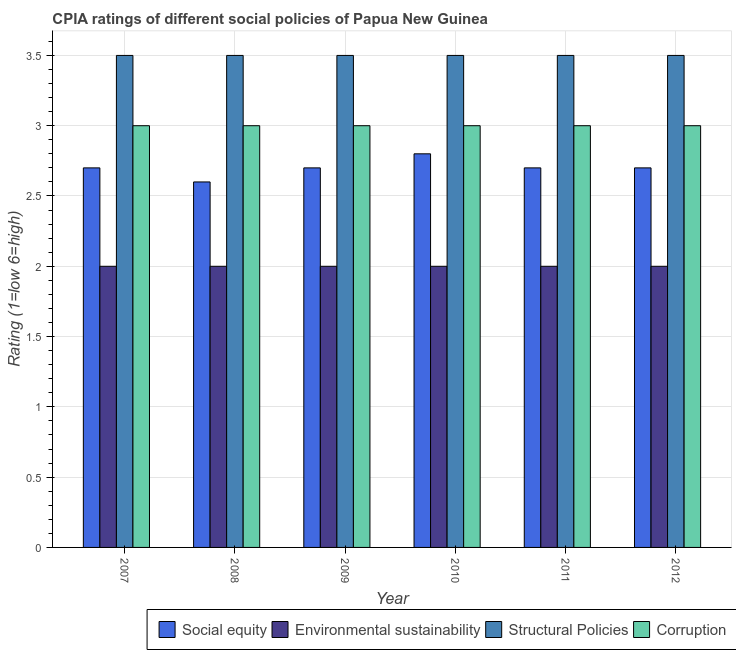How many different coloured bars are there?
Keep it short and to the point. 4. How many groups of bars are there?
Provide a succinct answer. 6. Are the number of bars per tick equal to the number of legend labels?
Make the answer very short. Yes. What is the label of the 5th group of bars from the left?
Provide a succinct answer. 2011. In how many cases, is the number of bars for a given year not equal to the number of legend labels?
Your response must be concise. 0. What is the cpia rating of social equity in 2008?
Offer a terse response. 2.6. Across all years, what is the maximum cpia rating of structural policies?
Ensure brevity in your answer.  3.5. Across all years, what is the minimum cpia rating of social equity?
Offer a very short reply. 2.6. In which year was the cpia rating of corruption maximum?
Offer a terse response. 2007. What is the difference between the cpia rating of social equity in 2009 and the cpia rating of corruption in 2011?
Keep it short and to the point. 0. What is the average cpia rating of environmental sustainability per year?
Offer a very short reply. 2. In how many years, is the cpia rating of social equity greater than 3?
Your answer should be very brief. 0. Is the cpia rating of social equity in 2007 less than that in 2012?
Provide a succinct answer. No. Is the difference between the cpia rating of environmental sustainability in 2007 and 2009 greater than the difference between the cpia rating of corruption in 2007 and 2009?
Ensure brevity in your answer.  No. What is the difference between the highest and the second highest cpia rating of environmental sustainability?
Ensure brevity in your answer.  0. Is it the case that in every year, the sum of the cpia rating of structural policies and cpia rating of corruption is greater than the sum of cpia rating of social equity and cpia rating of environmental sustainability?
Your answer should be very brief. Yes. What does the 3rd bar from the left in 2008 represents?
Provide a succinct answer. Structural Policies. What does the 1st bar from the right in 2010 represents?
Ensure brevity in your answer.  Corruption. How many bars are there?
Provide a succinct answer. 24. What is the difference between two consecutive major ticks on the Y-axis?
Make the answer very short. 0.5. Does the graph contain any zero values?
Your answer should be very brief. No. Where does the legend appear in the graph?
Make the answer very short. Bottom right. How many legend labels are there?
Your answer should be compact. 4. What is the title of the graph?
Give a very brief answer. CPIA ratings of different social policies of Papua New Guinea. What is the label or title of the X-axis?
Your answer should be very brief. Year. What is the Rating (1=low 6=high) of Environmental sustainability in 2007?
Offer a very short reply. 2. What is the Rating (1=low 6=high) in Structural Policies in 2007?
Give a very brief answer. 3.5. What is the Rating (1=low 6=high) in Structural Policies in 2008?
Provide a short and direct response. 3.5. What is the Rating (1=low 6=high) of Corruption in 2008?
Keep it short and to the point. 3. What is the Rating (1=low 6=high) of Environmental sustainability in 2010?
Offer a terse response. 2. What is the Rating (1=low 6=high) of Structural Policies in 2010?
Keep it short and to the point. 3.5. What is the Rating (1=low 6=high) of Environmental sustainability in 2011?
Give a very brief answer. 2. What is the Rating (1=low 6=high) of Environmental sustainability in 2012?
Ensure brevity in your answer.  2. What is the Rating (1=low 6=high) of Structural Policies in 2012?
Provide a short and direct response. 3.5. What is the Rating (1=low 6=high) in Corruption in 2012?
Provide a short and direct response. 3. Across all years, what is the maximum Rating (1=low 6=high) in Social equity?
Your response must be concise. 2.8. Across all years, what is the maximum Rating (1=low 6=high) in Environmental sustainability?
Your response must be concise. 2. Across all years, what is the maximum Rating (1=low 6=high) of Structural Policies?
Make the answer very short. 3.5. Across all years, what is the minimum Rating (1=low 6=high) of Social equity?
Your answer should be compact. 2.6. What is the total Rating (1=low 6=high) in Social equity in the graph?
Offer a terse response. 16.2. What is the difference between the Rating (1=low 6=high) in Structural Policies in 2007 and that in 2008?
Provide a succinct answer. 0. What is the difference between the Rating (1=low 6=high) in Corruption in 2007 and that in 2008?
Give a very brief answer. 0. What is the difference between the Rating (1=low 6=high) in Social equity in 2007 and that in 2009?
Provide a succinct answer. 0. What is the difference between the Rating (1=low 6=high) in Structural Policies in 2007 and that in 2009?
Your response must be concise. 0. What is the difference between the Rating (1=low 6=high) in Social equity in 2007 and that in 2011?
Your answer should be compact. 0. What is the difference between the Rating (1=low 6=high) in Structural Policies in 2007 and that in 2011?
Provide a short and direct response. 0. What is the difference between the Rating (1=low 6=high) in Social equity in 2007 and that in 2012?
Your answer should be very brief. 0. What is the difference between the Rating (1=low 6=high) in Corruption in 2007 and that in 2012?
Your answer should be compact. 0. What is the difference between the Rating (1=low 6=high) of Corruption in 2008 and that in 2010?
Your response must be concise. 0. What is the difference between the Rating (1=low 6=high) in Social equity in 2008 and that in 2011?
Your answer should be very brief. -0.1. What is the difference between the Rating (1=low 6=high) of Environmental sustainability in 2008 and that in 2011?
Offer a very short reply. 0. What is the difference between the Rating (1=low 6=high) of Social equity in 2008 and that in 2012?
Your answer should be compact. -0.1. What is the difference between the Rating (1=low 6=high) of Structural Policies in 2008 and that in 2012?
Your answer should be compact. 0. What is the difference between the Rating (1=low 6=high) of Social equity in 2009 and that in 2010?
Offer a terse response. -0.1. What is the difference between the Rating (1=low 6=high) in Environmental sustainability in 2009 and that in 2010?
Provide a succinct answer. 0. What is the difference between the Rating (1=low 6=high) of Structural Policies in 2009 and that in 2010?
Your answer should be compact. 0. What is the difference between the Rating (1=low 6=high) in Corruption in 2009 and that in 2010?
Provide a succinct answer. 0. What is the difference between the Rating (1=low 6=high) in Environmental sustainability in 2009 and that in 2011?
Provide a succinct answer. 0. What is the difference between the Rating (1=low 6=high) of Environmental sustainability in 2009 and that in 2012?
Ensure brevity in your answer.  0. What is the difference between the Rating (1=low 6=high) in Corruption in 2009 and that in 2012?
Give a very brief answer. 0. What is the difference between the Rating (1=low 6=high) of Social equity in 2010 and that in 2011?
Provide a short and direct response. 0.1. What is the difference between the Rating (1=low 6=high) of Social equity in 2010 and that in 2012?
Ensure brevity in your answer.  0.1. What is the difference between the Rating (1=low 6=high) of Environmental sustainability in 2010 and that in 2012?
Keep it short and to the point. 0. What is the difference between the Rating (1=low 6=high) in Structural Policies in 2011 and that in 2012?
Your answer should be compact. 0. What is the difference between the Rating (1=low 6=high) in Corruption in 2011 and that in 2012?
Ensure brevity in your answer.  0. What is the difference between the Rating (1=low 6=high) in Environmental sustainability in 2007 and the Rating (1=low 6=high) in Corruption in 2008?
Provide a succinct answer. -1. What is the difference between the Rating (1=low 6=high) of Social equity in 2007 and the Rating (1=low 6=high) of Environmental sustainability in 2009?
Ensure brevity in your answer.  0.7. What is the difference between the Rating (1=low 6=high) of Social equity in 2007 and the Rating (1=low 6=high) of Structural Policies in 2009?
Offer a terse response. -0.8. What is the difference between the Rating (1=low 6=high) in Social equity in 2007 and the Rating (1=low 6=high) in Corruption in 2009?
Keep it short and to the point. -0.3. What is the difference between the Rating (1=low 6=high) of Environmental sustainability in 2007 and the Rating (1=low 6=high) of Structural Policies in 2009?
Keep it short and to the point. -1.5. What is the difference between the Rating (1=low 6=high) of Social equity in 2007 and the Rating (1=low 6=high) of Corruption in 2010?
Provide a short and direct response. -0.3. What is the difference between the Rating (1=low 6=high) in Environmental sustainability in 2007 and the Rating (1=low 6=high) in Structural Policies in 2010?
Your answer should be compact. -1.5. What is the difference between the Rating (1=low 6=high) of Social equity in 2007 and the Rating (1=low 6=high) of Environmental sustainability in 2011?
Ensure brevity in your answer.  0.7. What is the difference between the Rating (1=low 6=high) of Environmental sustainability in 2007 and the Rating (1=low 6=high) of Corruption in 2011?
Your answer should be compact. -1. What is the difference between the Rating (1=low 6=high) of Social equity in 2007 and the Rating (1=low 6=high) of Environmental sustainability in 2012?
Offer a terse response. 0.7. What is the difference between the Rating (1=low 6=high) in Social equity in 2008 and the Rating (1=low 6=high) in Environmental sustainability in 2009?
Your response must be concise. 0.6. What is the difference between the Rating (1=low 6=high) in Social equity in 2008 and the Rating (1=low 6=high) in Corruption in 2009?
Keep it short and to the point. -0.4. What is the difference between the Rating (1=low 6=high) in Structural Policies in 2008 and the Rating (1=low 6=high) in Corruption in 2009?
Offer a very short reply. 0.5. What is the difference between the Rating (1=low 6=high) in Social equity in 2008 and the Rating (1=low 6=high) in Environmental sustainability in 2010?
Ensure brevity in your answer.  0.6. What is the difference between the Rating (1=low 6=high) in Social equity in 2008 and the Rating (1=low 6=high) in Corruption in 2010?
Ensure brevity in your answer.  -0.4. What is the difference between the Rating (1=low 6=high) of Environmental sustainability in 2008 and the Rating (1=low 6=high) of Structural Policies in 2010?
Make the answer very short. -1.5. What is the difference between the Rating (1=low 6=high) in Environmental sustainability in 2008 and the Rating (1=low 6=high) in Corruption in 2010?
Keep it short and to the point. -1. What is the difference between the Rating (1=low 6=high) in Structural Policies in 2008 and the Rating (1=low 6=high) in Corruption in 2010?
Make the answer very short. 0.5. What is the difference between the Rating (1=low 6=high) of Social equity in 2008 and the Rating (1=low 6=high) of Structural Policies in 2011?
Keep it short and to the point. -0.9. What is the difference between the Rating (1=low 6=high) in Social equity in 2008 and the Rating (1=low 6=high) in Corruption in 2011?
Make the answer very short. -0.4. What is the difference between the Rating (1=low 6=high) in Environmental sustainability in 2008 and the Rating (1=low 6=high) in Structural Policies in 2011?
Ensure brevity in your answer.  -1.5. What is the difference between the Rating (1=low 6=high) of Environmental sustainability in 2008 and the Rating (1=low 6=high) of Corruption in 2011?
Your answer should be compact. -1. What is the difference between the Rating (1=low 6=high) of Structural Policies in 2008 and the Rating (1=low 6=high) of Corruption in 2011?
Ensure brevity in your answer.  0.5. What is the difference between the Rating (1=low 6=high) in Social equity in 2008 and the Rating (1=low 6=high) in Environmental sustainability in 2012?
Keep it short and to the point. 0.6. What is the difference between the Rating (1=low 6=high) of Social equity in 2008 and the Rating (1=low 6=high) of Structural Policies in 2012?
Make the answer very short. -0.9. What is the difference between the Rating (1=low 6=high) of Social equity in 2008 and the Rating (1=low 6=high) of Corruption in 2012?
Provide a short and direct response. -0.4. What is the difference between the Rating (1=low 6=high) of Environmental sustainability in 2008 and the Rating (1=low 6=high) of Structural Policies in 2012?
Your response must be concise. -1.5. What is the difference between the Rating (1=low 6=high) in Social equity in 2009 and the Rating (1=low 6=high) in Structural Policies in 2010?
Give a very brief answer. -0.8. What is the difference between the Rating (1=low 6=high) in Environmental sustainability in 2009 and the Rating (1=low 6=high) in Structural Policies in 2010?
Ensure brevity in your answer.  -1.5. What is the difference between the Rating (1=low 6=high) in Environmental sustainability in 2009 and the Rating (1=low 6=high) in Corruption in 2010?
Ensure brevity in your answer.  -1. What is the difference between the Rating (1=low 6=high) of Social equity in 2009 and the Rating (1=low 6=high) of Corruption in 2011?
Provide a short and direct response. -0.3. What is the difference between the Rating (1=low 6=high) in Social equity in 2009 and the Rating (1=low 6=high) in Environmental sustainability in 2012?
Ensure brevity in your answer.  0.7. What is the difference between the Rating (1=low 6=high) in Social equity in 2009 and the Rating (1=low 6=high) in Structural Policies in 2012?
Offer a very short reply. -0.8. What is the difference between the Rating (1=low 6=high) in Environmental sustainability in 2009 and the Rating (1=low 6=high) in Structural Policies in 2012?
Your answer should be very brief. -1.5. What is the difference between the Rating (1=low 6=high) of Environmental sustainability in 2009 and the Rating (1=low 6=high) of Corruption in 2012?
Provide a succinct answer. -1. What is the difference between the Rating (1=low 6=high) in Social equity in 2010 and the Rating (1=low 6=high) in Structural Policies in 2011?
Offer a very short reply. -0.7. What is the difference between the Rating (1=low 6=high) of Environmental sustainability in 2010 and the Rating (1=low 6=high) of Structural Policies in 2011?
Provide a succinct answer. -1.5. What is the difference between the Rating (1=low 6=high) in Structural Policies in 2010 and the Rating (1=low 6=high) in Corruption in 2011?
Offer a terse response. 0.5. What is the difference between the Rating (1=low 6=high) of Social equity in 2010 and the Rating (1=low 6=high) of Environmental sustainability in 2012?
Your answer should be compact. 0.8. What is the difference between the Rating (1=low 6=high) in Social equity in 2010 and the Rating (1=low 6=high) in Structural Policies in 2012?
Make the answer very short. -0.7. What is the difference between the Rating (1=low 6=high) of Social equity in 2010 and the Rating (1=low 6=high) of Corruption in 2012?
Provide a short and direct response. -0.2. What is the difference between the Rating (1=low 6=high) in Environmental sustainability in 2010 and the Rating (1=low 6=high) in Corruption in 2012?
Provide a short and direct response. -1. What is the difference between the Rating (1=low 6=high) of Social equity in 2011 and the Rating (1=low 6=high) of Environmental sustainability in 2012?
Your response must be concise. 0.7. What is the difference between the Rating (1=low 6=high) in Social equity in 2011 and the Rating (1=low 6=high) in Structural Policies in 2012?
Provide a short and direct response. -0.8. What is the average Rating (1=low 6=high) of Environmental sustainability per year?
Provide a succinct answer. 2. In the year 2007, what is the difference between the Rating (1=low 6=high) in Environmental sustainability and Rating (1=low 6=high) in Structural Policies?
Make the answer very short. -1.5. In the year 2007, what is the difference between the Rating (1=low 6=high) of Environmental sustainability and Rating (1=low 6=high) of Corruption?
Make the answer very short. -1. In the year 2007, what is the difference between the Rating (1=low 6=high) in Structural Policies and Rating (1=low 6=high) in Corruption?
Offer a very short reply. 0.5. In the year 2008, what is the difference between the Rating (1=low 6=high) in Social equity and Rating (1=low 6=high) in Environmental sustainability?
Offer a terse response. 0.6. In the year 2008, what is the difference between the Rating (1=low 6=high) in Social equity and Rating (1=low 6=high) in Corruption?
Your answer should be very brief. -0.4. In the year 2008, what is the difference between the Rating (1=low 6=high) in Environmental sustainability and Rating (1=low 6=high) in Structural Policies?
Keep it short and to the point. -1.5. In the year 2009, what is the difference between the Rating (1=low 6=high) in Social equity and Rating (1=low 6=high) in Environmental sustainability?
Ensure brevity in your answer.  0.7. In the year 2009, what is the difference between the Rating (1=low 6=high) of Social equity and Rating (1=low 6=high) of Structural Policies?
Provide a short and direct response. -0.8. In the year 2009, what is the difference between the Rating (1=low 6=high) of Social equity and Rating (1=low 6=high) of Corruption?
Give a very brief answer. -0.3. In the year 2009, what is the difference between the Rating (1=low 6=high) in Environmental sustainability and Rating (1=low 6=high) in Structural Policies?
Provide a short and direct response. -1.5. In the year 2010, what is the difference between the Rating (1=low 6=high) in Social equity and Rating (1=low 6=high) in Structural Policies?
Offer a very short reply. -0.7. In the year 2010, what is the difference between the Rating (1=low 6=high) of Environmental sustainability and Rating (1=low 6=high) of Structural Policies?
Make the answer very short. -1.5. In the year 2010, what is the difference between the Rating (1=low 6=high) in Environmental sustainability and Rating (1=low 6=high) in Corruption?
Provide a succinct answer. -1. In the year 2011, what is the difference between the Rating (1=low 6=high) in Social equity and Rating (1=low 6=high) in Structural Policies?
Provide a succinct answer. -0.8. In the year 2011, what is the difference between the Rating (1=low 6=high) of Environmental sustainability and Rating (1=low 6=high) of Corruption?
Give a very brief answer. -1. In the year 2012, what is the difference between the Rating (1=low 6=high) of Social equity and Rating (1=low 6=high) of Environmental sustainability?
Give a very brief answer. 0.7. In the year 2012, what is the difference between the Rating (1=low 6=high) in Environmental sustainability and Rating (1=low 6=high) in Structural Policies?
Offer a terse response. -1.5. In the year 2012, what is the difference between the Rating (1=low 6=high) of Environmental sustainability and Rating (1=low 6=high) of Corruption?
Offer a terse response. -1. What is the ratio of the Rating (1=low 6=high) of Structural Policies in 2007 to that in 2008?
Make the answer very short. 1. What is the ratio of the Rating (1=low 6=high) in Corruption in 2007 to that in 2008?
Your answer should be compact. 1. What is the ratio of the Rating (1=low 6=high) of Social equity in 2007 to that in 2009?
Your answer should be very brief. 1. What is the ratio of the Rating (1=low 6=high) of Social equity in 2007 to that in 2010?
Your response must be concise. 0.96. What is the ratio of the Rating (1=low 6=high) of Structural Policies in 2007 to that in 2010?
Your answer should be compact. 1. What is the ratio of the Rating (1=low 6=high) in Social equity in 2007 to that in 2011?
Ensure brevity in your answer.  1. What is the ratio of the Rating (1=low 6=high) of Environmental sustainability in 2007 to that in 2011?
Give a very brief answer. 1. What is the ratio of the Rating (1=low 6=high) of Structural Policies in 2007 to that in 2011?
Offer a very short reply. 1. What is the ratio of the Rating (1=low 6=high) of Environmental sustainability in 2007 to that in 2012?
Offer a terse response. 1. What is the ratio of the Rating (1=low 6=high) of Social equity in 2008 to that in 2009?
Ensure brevity in your answer.  0.96. What is the ratio of the Rating (1=low 6=high) of Environmental sustainability in 2008 to that in 2009?
Your response must be concise. 1. What is the ratio of the Rating (1=low 6=high) in Structural Policies in 2008 to that in 2009?
Ensure brevity in your answer.  1. What is the ratio of the Rating (1=low 6=high) of Corruption in 2008 to that in 2009?
Your answer should be compact. 1. What is the ratio of the Rating (1=low 6=high) of Social equity in 2008 to that in 2010?
Offer a very short reply. 0.93. What is the ratio of the Rating (1=low 6=high) in Structural Policies in 2008 to that in 2010?
Your answer should be compact. 1. What is the ratio of the Rating (1=low 6=high) of Corruption in 2008 to that in 2010?
Ensure brevity in your answer.  1. What is the ratio of the Rating (1=low 6=high) in Environmental sustainability in 2008 to that in 2011?
Provide a succinct answer. 1. What is the ratio of the Rating (1=low 6=high) of Structural Policies in 2008 to that in 2011?
Your answer should be very brief. 1. What is the ratio of the Rating (1=low 6=high) in Structural Policies in 2008 to that in 2012?
Ensure brevity in your answer.  1. What is the ratio of the Rating (1=low 6=high) in Social equity in 2009 to that in 2010?
Your answer should be compact. 0.96. What is the ratio of the Rating (1=low 6=high) of Corruption in 2009 to that in 2010?
Ensure brevity in your answer.  1. What is the ratio of the Rating (1=low 6=high) in Social equity in 2009 to that in 2011?
Provide a short and direct response. 1. What is the ratio of the Rating (1=low 6=high) in Social equity in 2010 to that in 2011?
Offer a terse response. 1.04. What is the ratio of the Rating (1=low 6=high) of Environmental sustainability in 2010 to that in 2011?
Provide a short and direct response. 1. What is the ratio of the Rating (1=low 6=high) in Structural Policies in 2010 to that in 2011?
Offer a very short reply. 1. What is the ratio of the Rating (1=low 6=high) in Corruption in 2010 to that in 2011?
Offer a very short reply. 1. What is the ratio of the Rating (1=low 6=high) in Structural Policies in 2010 to that in 2012?
Your answer should be very brief. 1. What is the ratio of the Rating (1=low 6=high) of Corruption in 2010 to that in 2012?
Offer a terse response. 1. What is the ratio of the Rating (1=low 6=high) of Social equity in 2011 to that in 2012?
Make the answer very short. 1. What is the ratio of the Rating (1=low 6=high) of Environmental sustainability in 2011 to that in 2012?
Keep it short and to the point. 1. What is the ratio of the Rating (1=low 6=high) in Structural Policies in 2011 to that in 2012?
Ensure brevity in your answer.  1. What is the difference between the highest and the second highest Rating (1=low 6=high) of Social equity?
Ensure brevity in your answer.  0.1. What is the difference between the highest and the second highest Rating (1=low 6=high) in Environmental sustainability?
Your answer should be compact. 0. What is the difference between the highest and the second highest Rating (1=low 6=high) in Structural Policies?
Give a very brief answer. 0. What is the difference between the highest and the second highest Rating (1=low 6=high) in Corruption?
Give a very brief answer. 0. What is the difference between the highest and the lowest Rating (1=low 6=high) of Social equity?
Offer a terse response. 0.2. What is the difference between the highest and the lowest Rating (1=low 6=high) of Environmental sustainability?
Ensure brevity in your answer.  0. What is the difference between the highest and the lowest Rating (1=low 6=high) of Structural Policies?
Ensure brevity in your answer.  0. 